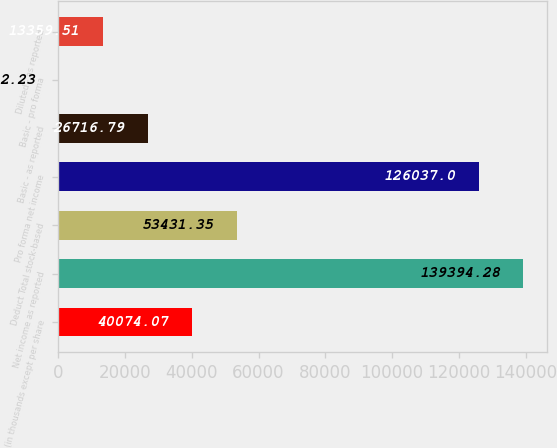Convert chart. <chart><loc_0><loc_0><loc_500><loc_500><bar_chart><fcel>(in thousands except per share<fcel>Net income as reported<fcel>Deduct Total stock-based<fcel>Pro forma net income<fcel>Basic - as reported<fcel>Basic - pro forma<fcel>Diluted - as reported<nl><fcel>40074.1<fcel>139394<fcel>53431.3<fcel>126037<fcel>26716.8<fcel>2.23<fcel>13359.5<nl></chart> 